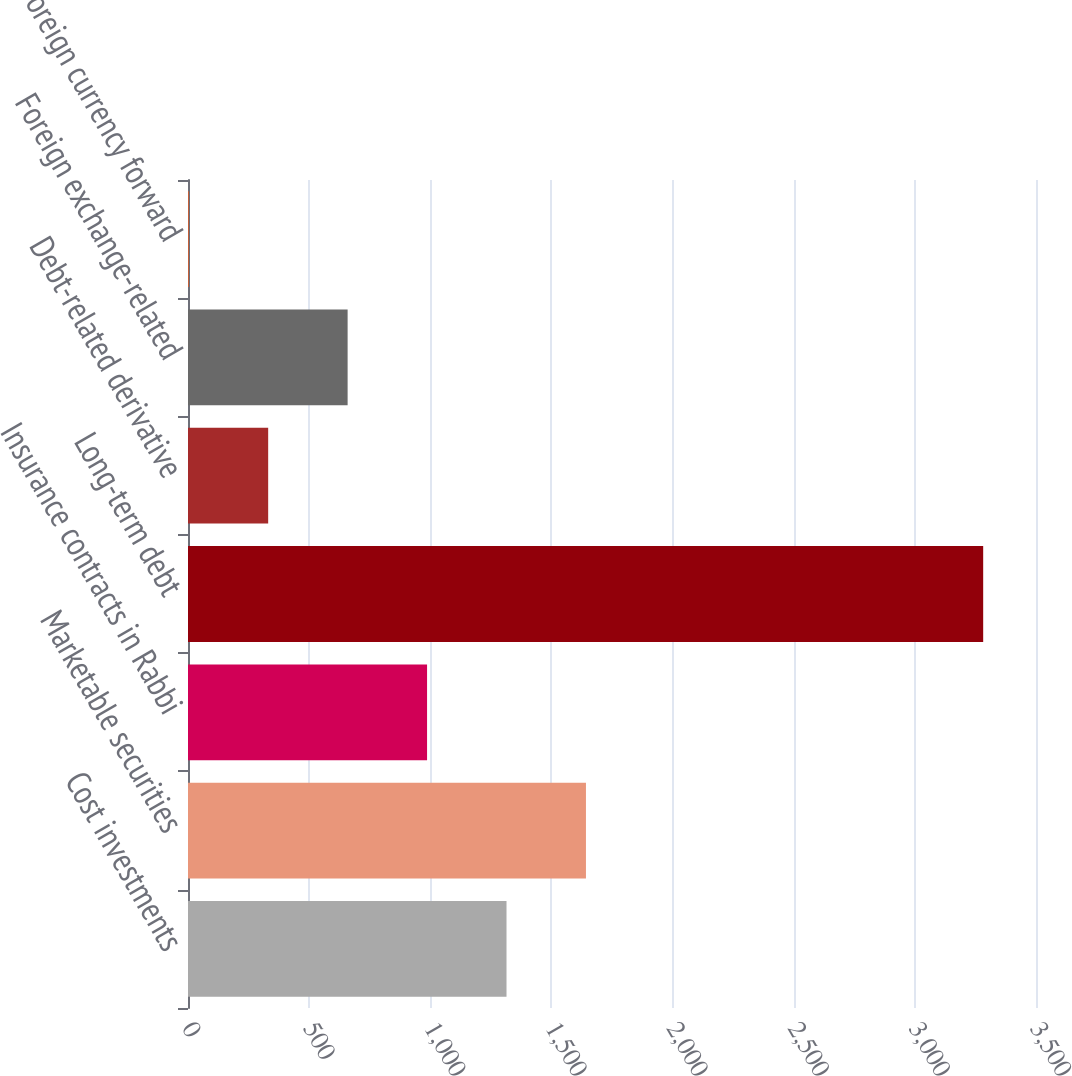Convert chart to OTSL. <chart><loc_0><loc_0><loc_500><loc_500><bar_chart><fcel>Cost investments<fcel>Marketable securities<fcel>Insurance contracts in Rabbi<fcel>Long-term debt<fcel>Debt-related derivative<fcel>Foreign exchange-related<fcel>Foreign currency forward<nl><fcel>1314.6<fcel>1642.5<fcel>986.7<fcel>3282<fcel>330.9<fcel>658.8<fcel>3<nl></chart> 